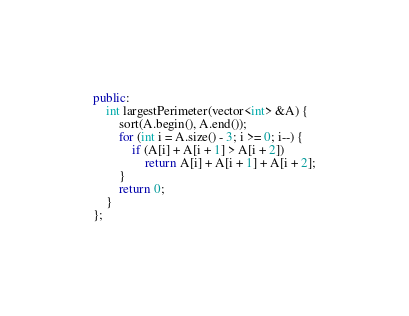<code> <loc_0><loc_0><loc_500><loc_500><_C++_>public:
    int largestPerimeter(vector<int> &A) {
        sort(A.begin(), A.end());
        for (int i = A.size() - 3; i >= 0; i--) {
            if (A[i] + A[i + 1] > A[i + 2])
                return A[i] + A[i + 1] + A[i + 2];
        }
        return 0;
    }
};
</code> 